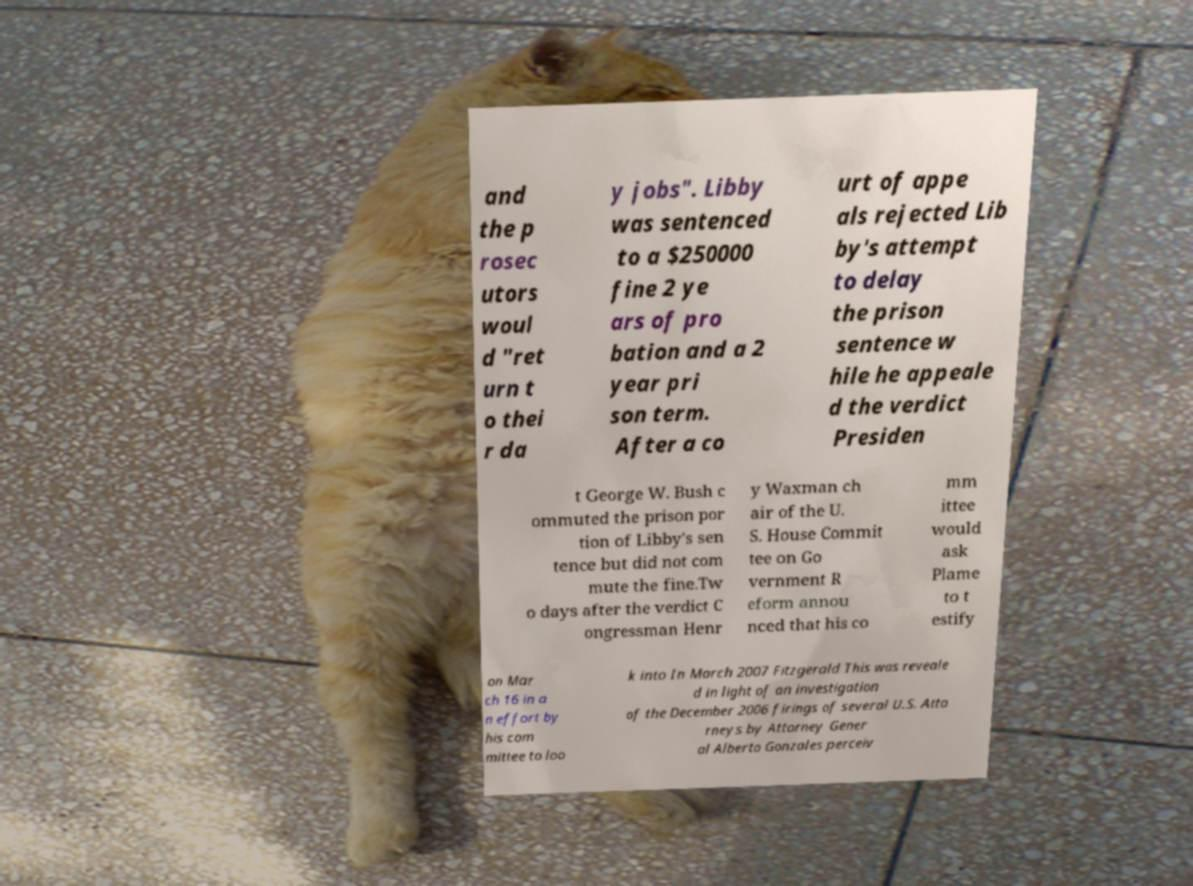What messages or text are displayed in this image? I need them in a readable, typed format. and the p rosec utors woul d "ret urn t o thei r da y jobs". Libby was sentenced to a $250000 fine 2 ye ars of pro bation and a 2 year pri son term. After a co urt of appe als rejected Lib by's attempt to delay the prison sentence w hile he appeale d the verdict Presiden t George W. Bush c ommuted the prison por tion of Libby's sen tence but did not com mute the fine.Tw o days after the verdict C ongressman Henr y Waxman ch air of the U. S. House Commit tee on Go vernment R eform annou nced that his co mm ittee would ask Plame to t estify on Mar ch 16 in a n effort by his com mittee to loo k into In March 2007 Fitzgerald This was reveale d in light of an investigation of the December 2006 firings of several U.S. Atto rneys by Attorney Gener al Alberto Gonzales perceiv 